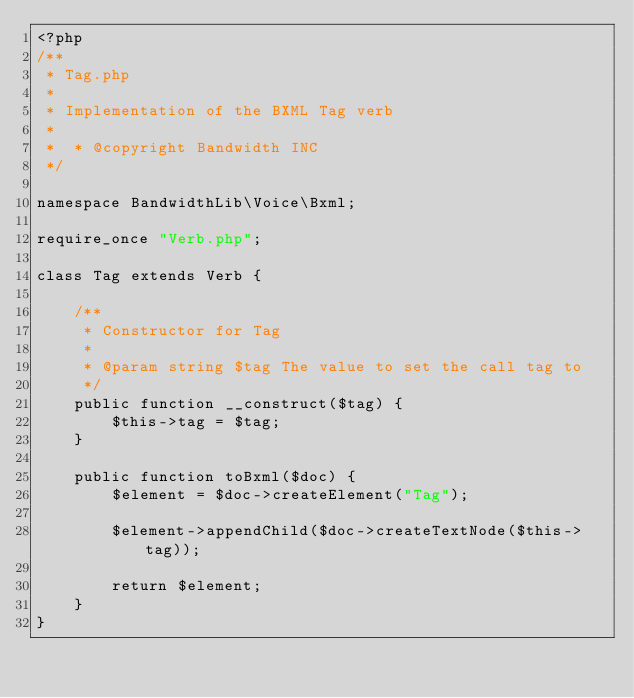<code> <loc_0><loc_0><loc_500><loc_500><_PHP_><?php
/**
 * Tag.php
 *
 * Implementation of the BXML Tag verb
 *
 *  * @copyright Bandwidth INC
 */
  
namespace BandwidthLib\Voice\Bxml;

require_once "Verb.php";

class Tag extends Verb {

    /**
     * Constructor for Tag
     *
     * @param string $tag The value to set the call tag to
     */
    public function __construct($tag) {
        $this->tag = $tag;
    }

    public function toBxml($doc) {
        $element = $doc->createElement("Tag");

        $element->appendChild($doc->createTextNode($this->tag));

        return $element;
    }
}
</code> 